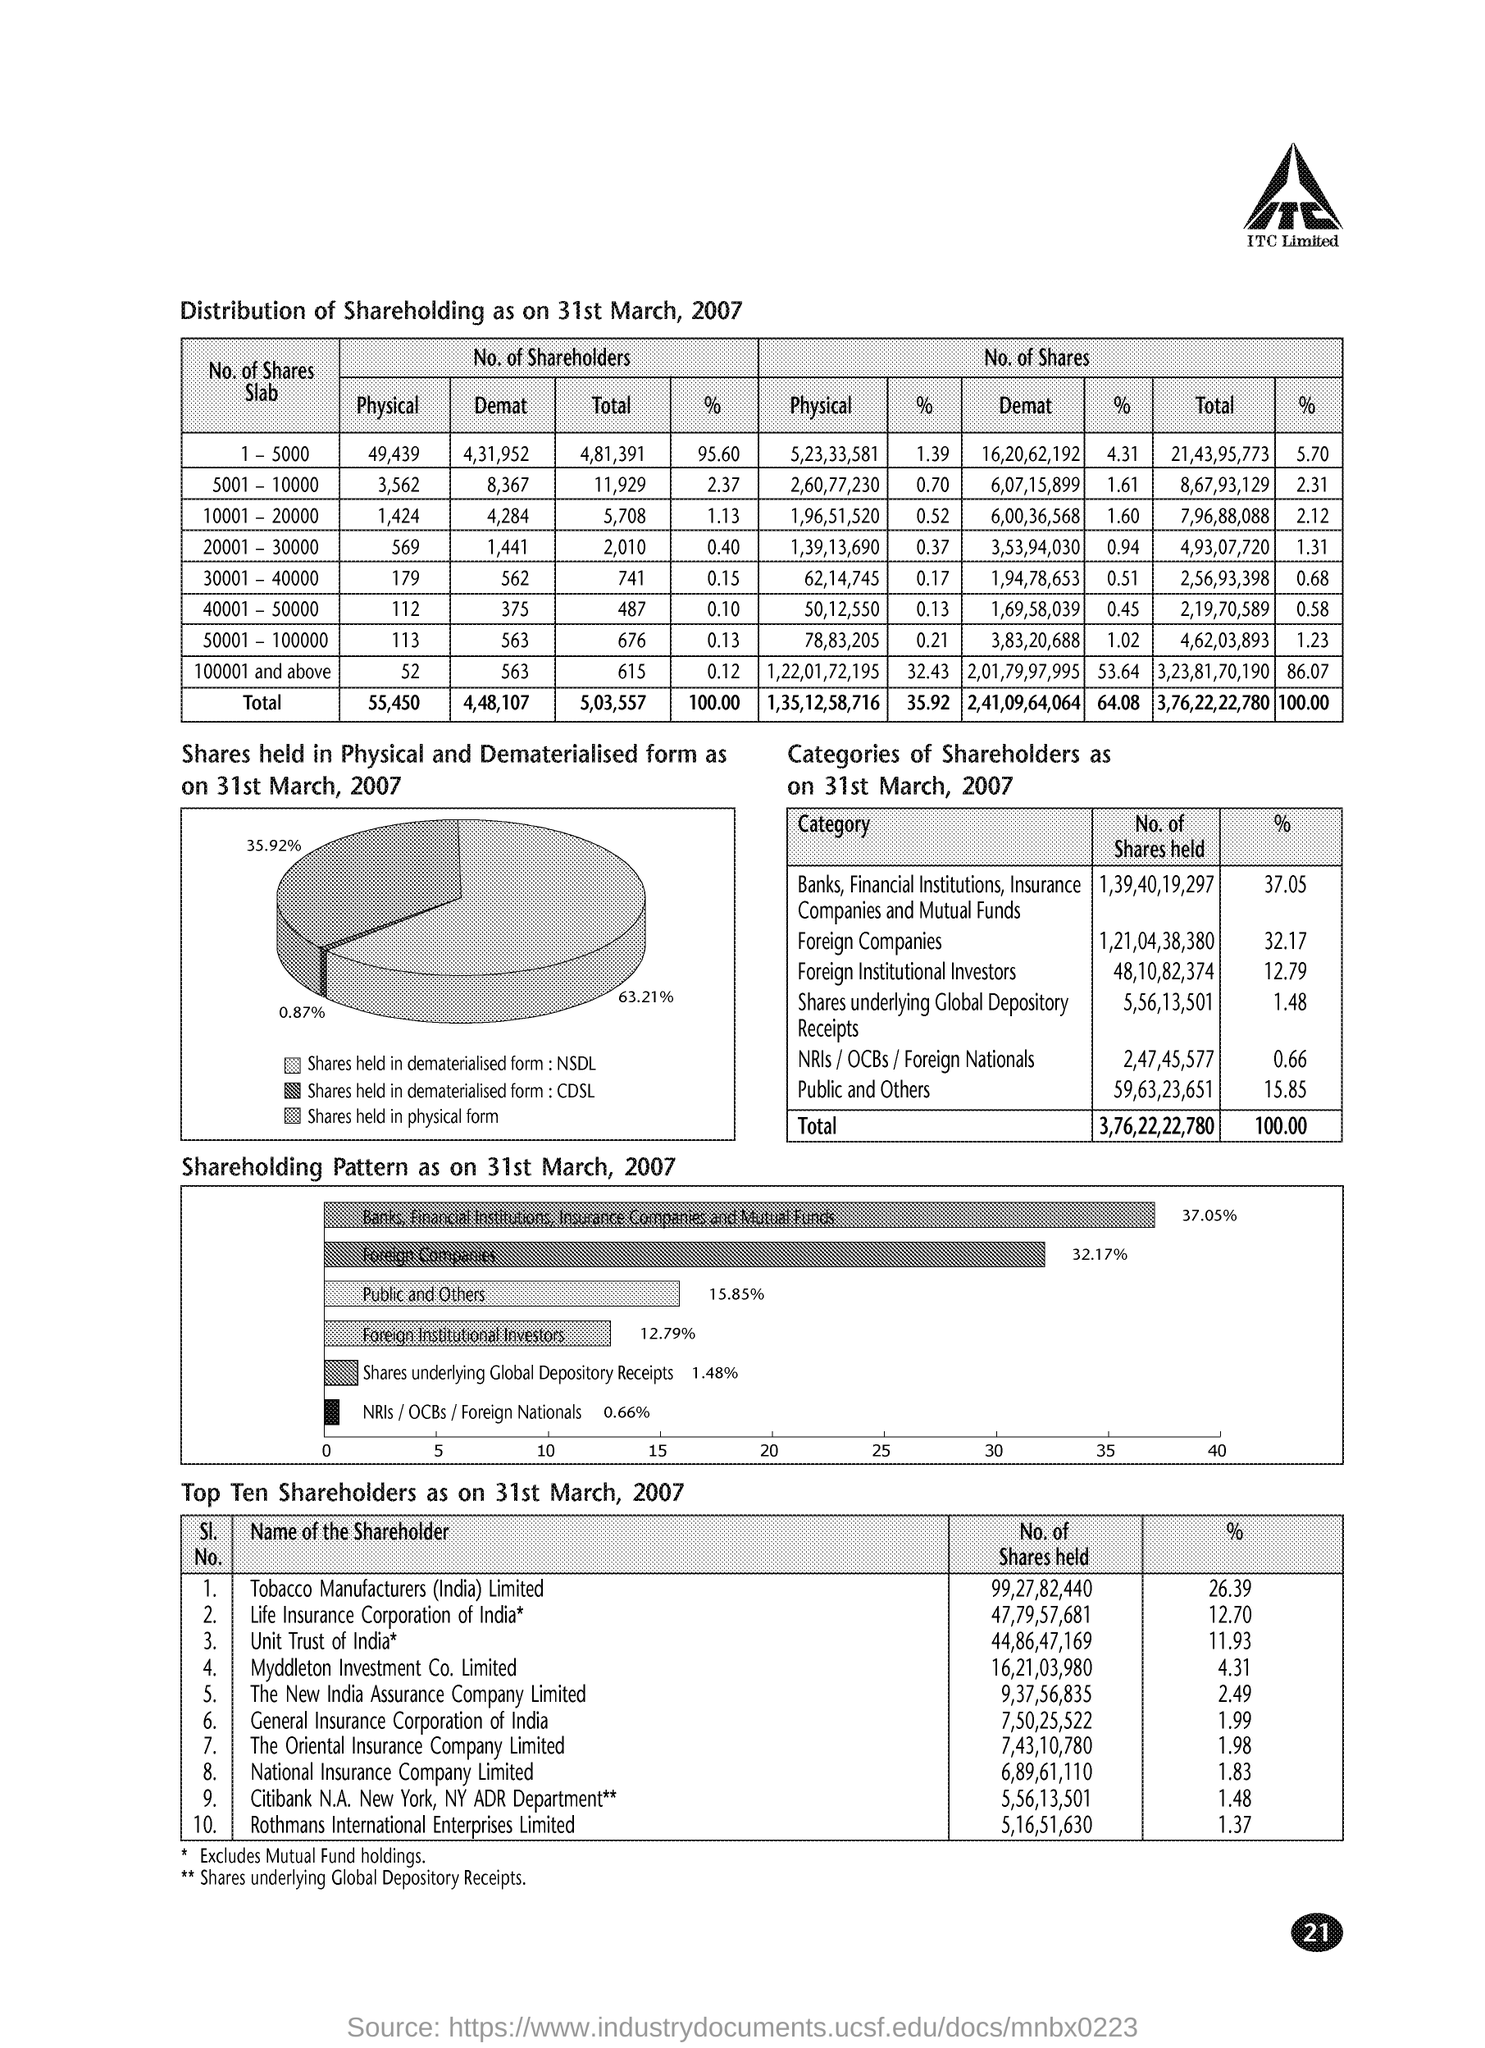Who are the top shareholders and what percentage of shares do they own? The top shareholders as of 31st March, 2007, are led by Tobacco Manufacturers (India) Limited holding 26.39% of the shares. They are followed by Life Insurance Corporation of India with 12.90%, Unit Trust of India owning 11.73%, Myddleton Investment Co. Limited with 4.31%, and other notable shareholders, including several insurance companies and an international entity. These top shareholders possess varied percentage stakes, indicating the variety and spread of interest in the company's equity. 